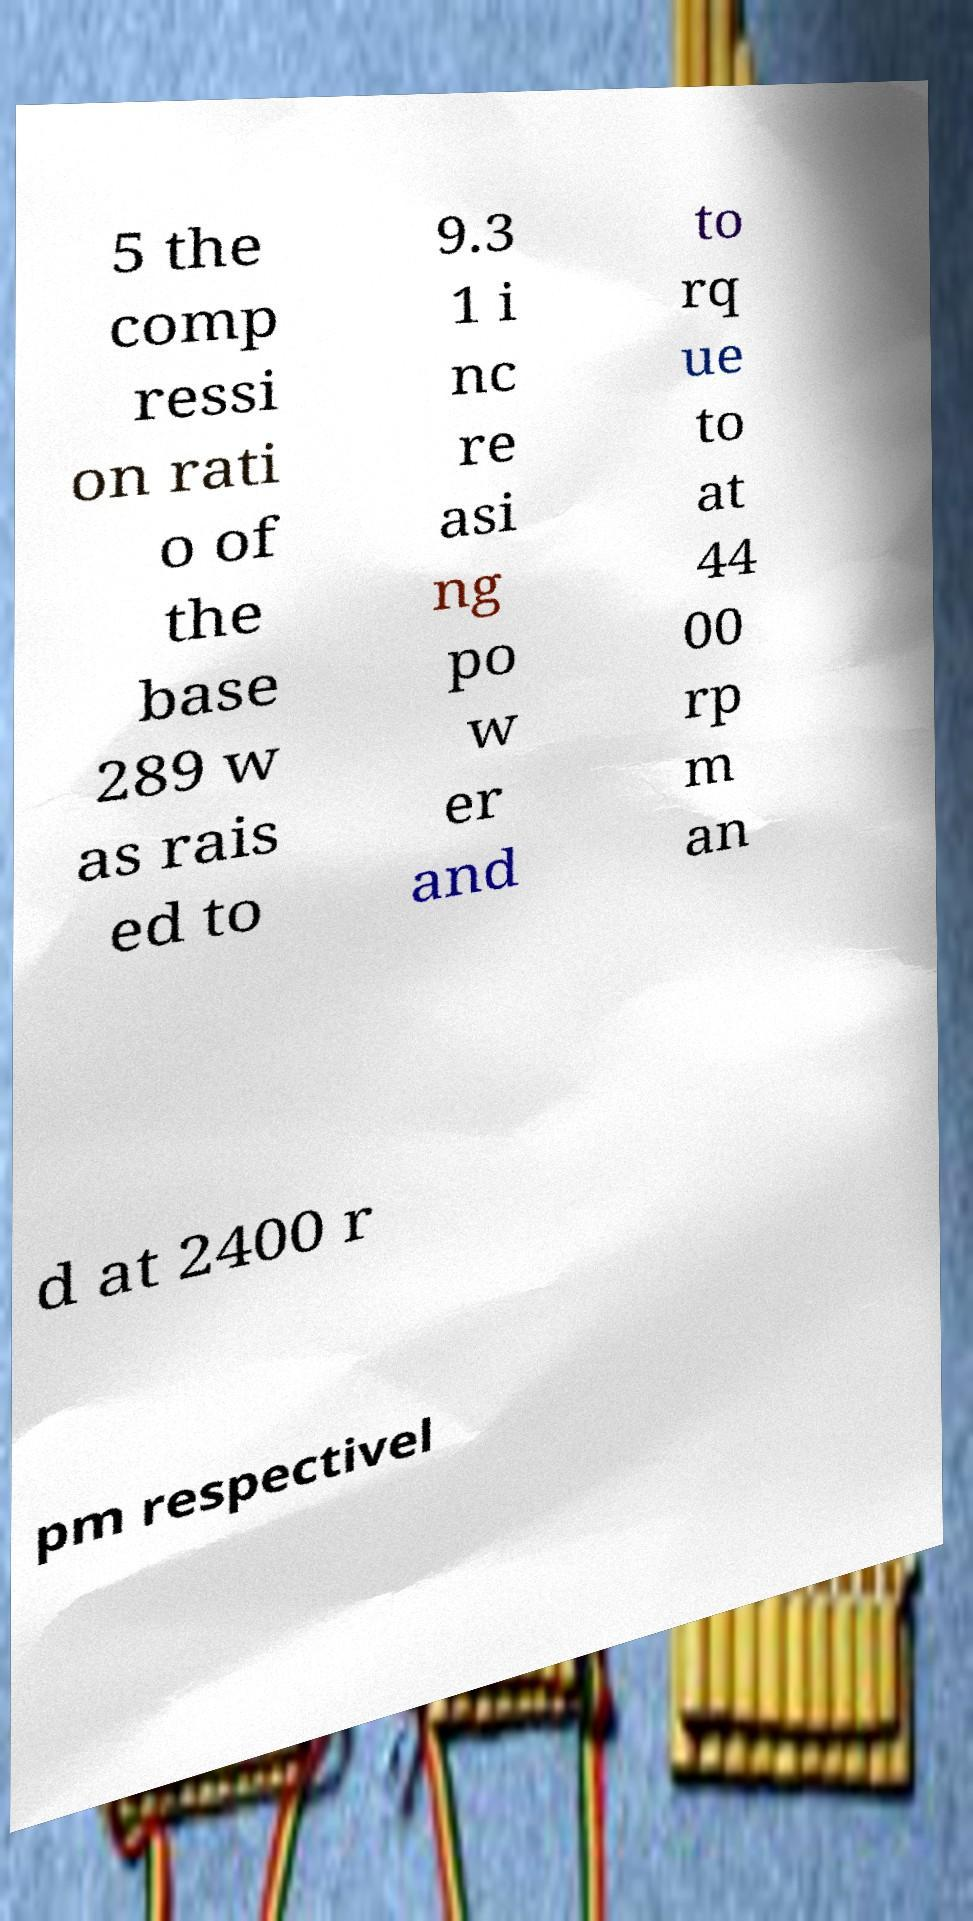Can you read and provide the text displayed in the image?This photo seems to have some interesting text. Can you extract and type it out for me? 5 the comp ressi on rati o of the base 289 w as rais ed to 9.3 1 i nc re asi ng po w er and to rq ue to at 44 00 rp m an d at 2400 r pm respectivel 